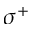<formula> <loc_0><loc_0><loc_500><loc_500>\sigma ^ { + }</formula> 